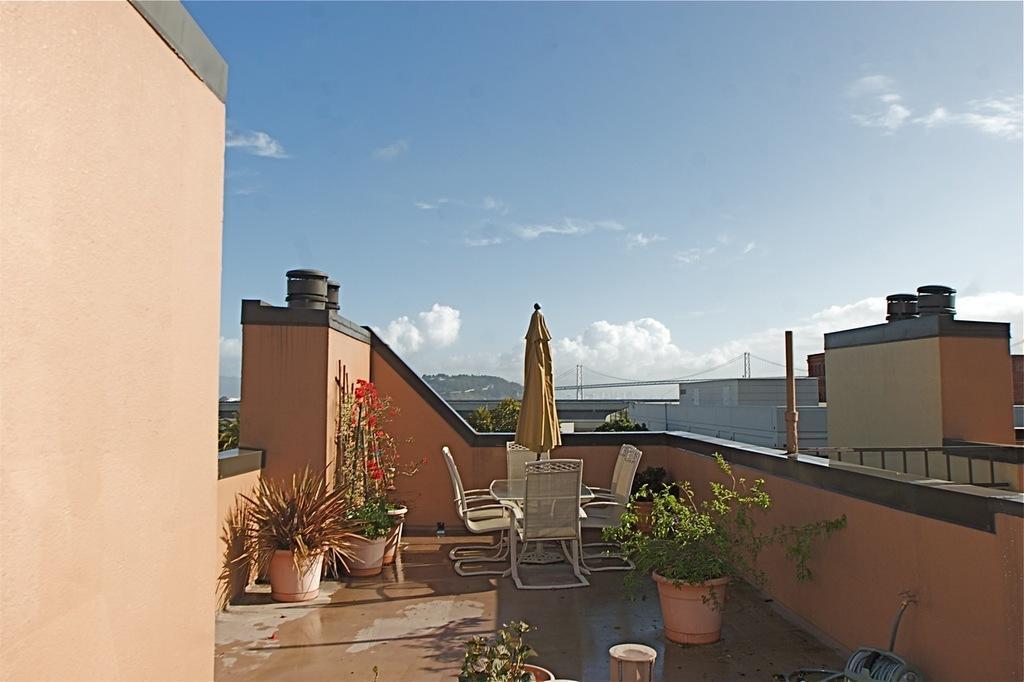Please provide a concise description of this image. This image is taken on a building top, where we can see few potted plants, table, chairs and an umbrella. In the background, there are buildings, trees, it seems like a bridge, a cliff, sky and the cloud. 